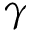<formula> <loc_0><loc_0><loc_500><loc_500>\gamma</formula> 